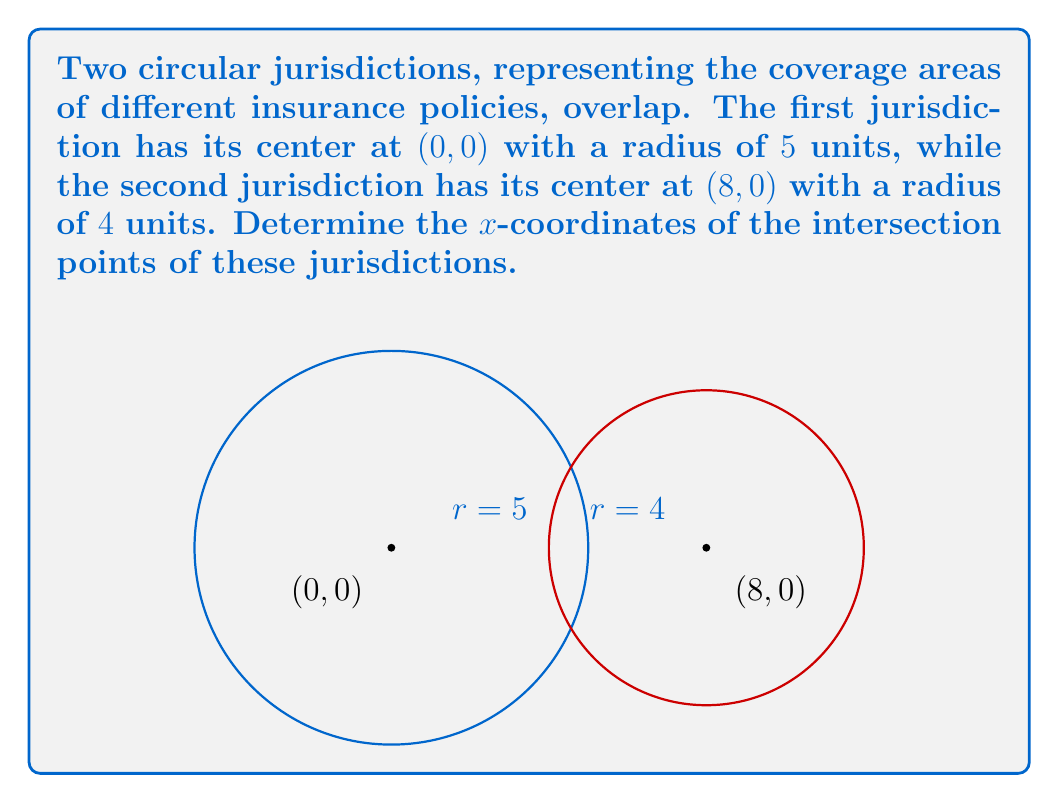Could you help me with this problem? To solve this problem, we'll follow these steps:

1) The equation of the first circle (centered at the origin) is:
   $$x^2 + y^2 = 25$$

2) The equation of the second circle (centered at (8,0)) is:
   $$(x-8)^2 + y^2 = 16$$

3) At the intersection points, both equations are satisfied. Subtracting the second equation from the first:
   $$x^2 + y^2 - ((x-8)^2 + y^2) = 25 - 16$$
   $$x^2 - (x^2 - 16x + 64) = 9$$
   $$16x - 64 = 9$$
   $$16x = 73$$
   $$x = \frac{73}{16} = 4.5625$$

4) This x-coordinate represents the midpoint between the two intersection points.

5) To find the actual x-coordinates of the intersection points, we need to calculate the distance from this midpoint to either intersection point along the x-axis.

6) We can do this by substituting x = 4.5625 into either circle equation and solving for y:
   $$y^2 = 25 - 4.5625^2 = 4.2539$$
   $$y = \pm\sqrt{4.2539} = \pm2.0625$$

7) Now we can use the Pythagorean theorem to find the distance d from the midpoint to either intersection point:
   $$d^2 + 2.0625^2 = 5^2$$
   $$d^2 = 25 - 4.2539 = 20.7461$$
   $$d = \sqrt{20.7461} = 4.5547$$

8) Therefore, the x-coordinates of the intersection points are:
   $$4.5625 - 4.5547 = 0.0078$$ and $$4.5625 + 4.5547 = 9.1172$$
Answer: $x \approx 0.0078$ and $x \approx 9.1172$ 